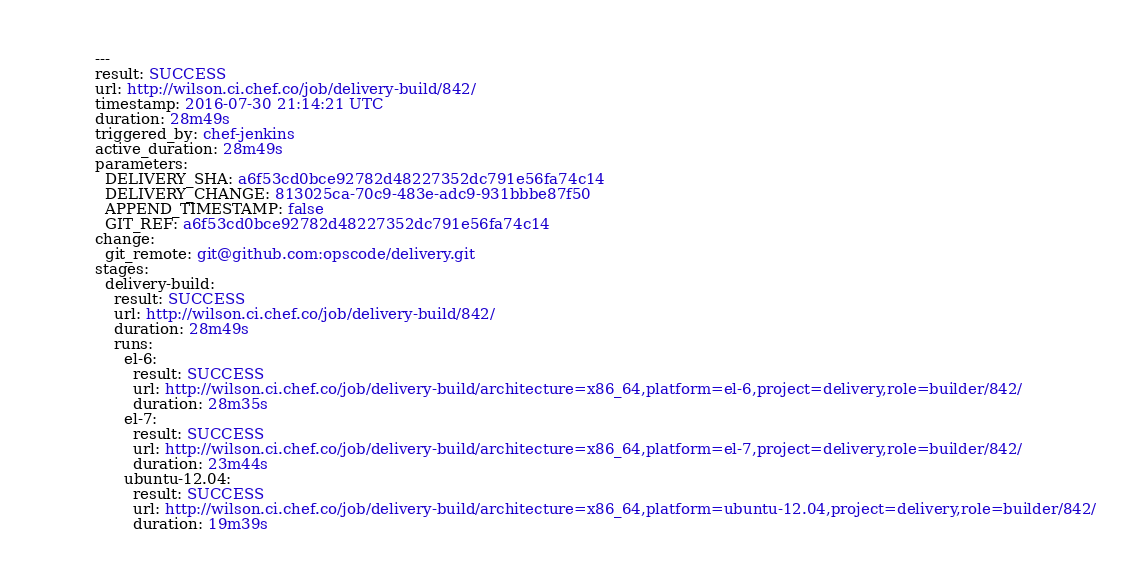<code> <loc_0><loc_0><loc_500><loc_500><_YAML_>---
result: SUCCESS
url: http://wilson.ci.chef.co/job/delivery-build/842/
timestamp: 2016-07-30 21:14:21 UTC
duration: 28m49s
triggered_by: chef-jenkins
active_duration: 28m49s
parameters:
  DELIVERY_SHA: a6f53cd0bce92782d48227352dc791e56fa74c14
  DELIVERY_CHANGE: 813025ca-70c9-483e-adc9-931bbbe87f50
  APPEND_TIMESTAMP: false
  GIT_REF: a6f53cd0bce92782d48227352dc791e56fa74c14
change:
  git_remote: git@github.com:opscode/delivery.git
stages:
  delivery-build:
    result: SUCCESS
    url: http://wilson.ci.chef.co/job/delivery-build/842/
    duration: 28m49s
    runs:
      el-6:
        result: SUCCESS
        url: http://wilson.ci.chef.co/job/delivery-build/architecture=x86_64,platform=el-6,project=delivery,role=builder/842/
        duration: 28m35s
      el-7:
        result: SUCCESS
        url: http://wilson.ci.chef.co/job/delivery-build/architecture=x86_64,platform=el-7,project=delivery,role=builder/842/
        duration: 23m44s
      ubuntu-12.04:
        result: SUCCESS
        url: http://wilson.ci.chef.co/job/delivery-build/architecture=x86_64,platform=ubuntu-12.04,project=delivery,role=builder/842/
        duration: 19m39s
</code> 